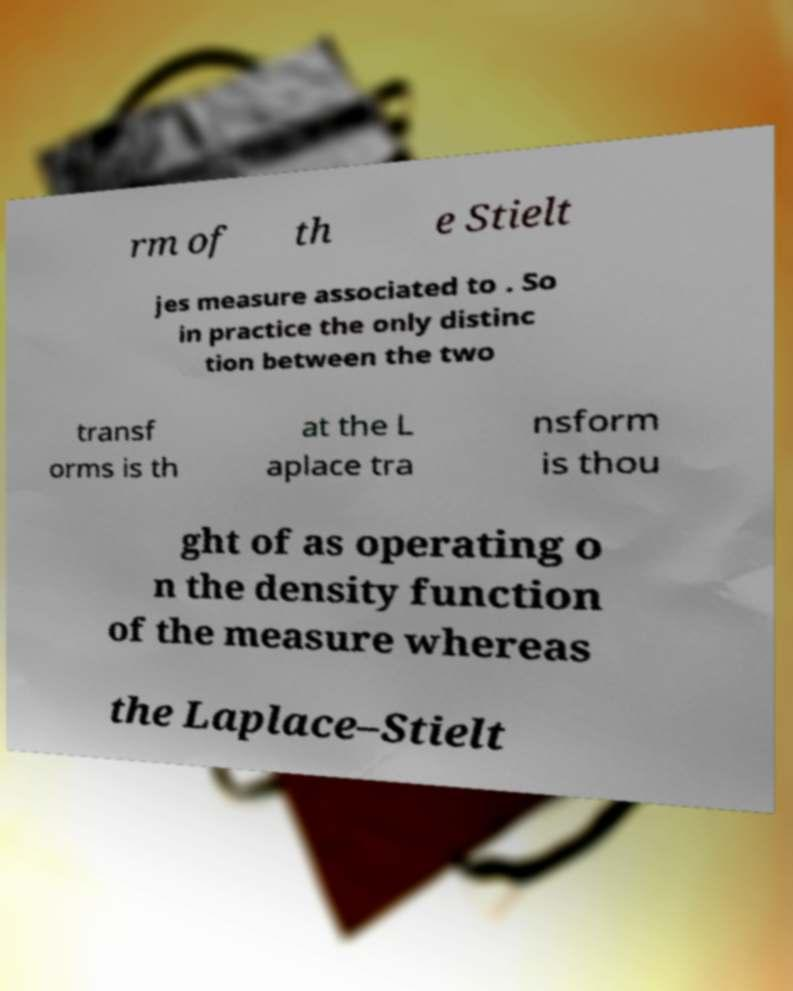Please identify and transcribe the text found in this image. rm of th e Stielt jes measure associated to . So in practice the only distinc tion between the two transf orms is th at the L aplace tra nsform is thou ght of as operating o n the density function of the measure whereas the Laplace–Stielt 